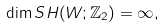Convert formula to latex. <formula><loc_0><loc_0><loc_500><loc_500>\dim S H ( W ; \mathbb { Z } _ { 2 } ) = \infty ,</formula> 